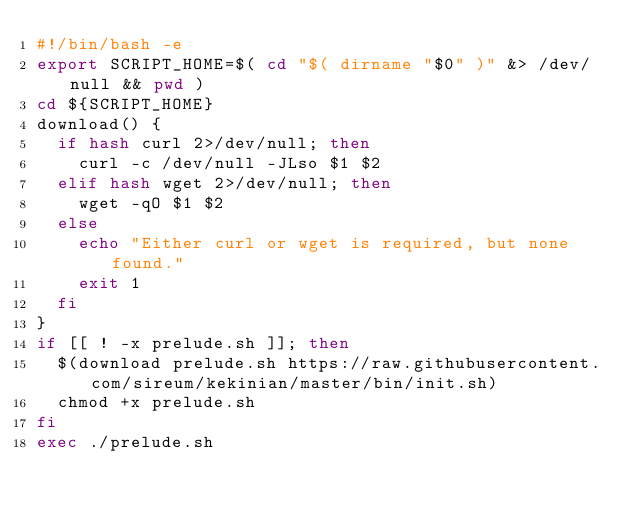Convert code to text. <code><loc_0><loc_0><loc_500><loc_500><_Bash_>#!/bin/bash -e
export SCRIPT_HOME=$( cd "$( dirname "$0" )" &> /dev/null && pwd )
cd ${SCRIPT_HOME}
download() {
  if hash curl 2>/dev/null; then
    curl -c /dev/null -JLso $1 $2
  elif hash wget 2>/dev/null; then
    wget -qO $1 $2
  else
    echo "Either curl or wget is required, but none found."
    exit 1
  fi
}
if [[ ! -x prelude.sh ]]; then
  $(download prelude.sh https://raw.githubusercontent.com/sireum/kekinian/master/bin/init.sh)
  chmod +x prelude.sh
fi
exec ./prelude.sh
</code> 